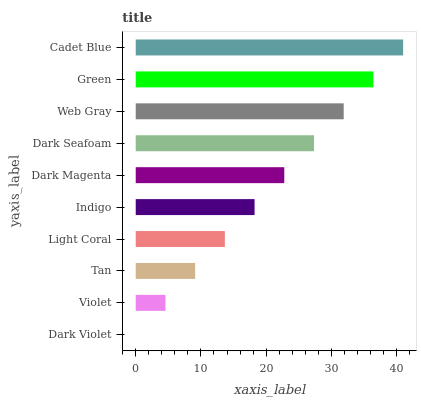Is Dark Violet the minimum?
Answer yes or no. Yes. Is Cadet Blue the maximum?
Answer yes or no. Yes. Is Violet the minimum?
Answer yes or no. No. Is Violet the maximum?
Answer yes or no. No. Is Violet greater than Dark Violet?
Answer yes or no. Yes. Is Dark Violet less than Violet?
Answer yes or no. Yes. Is Dark Violet greater than Violet?
Answer yes or no. No. Is Violet less than Dark Violet?
Answer yes or no. No. Is Dark Magenta the high median?
Answer yes or no. Yes. Is Indigo the low median?
Answer yes or no. Yes. Is Green the high median?
Answer yes or no. No. Is Tan the low median?
Answer yes or no. No. 